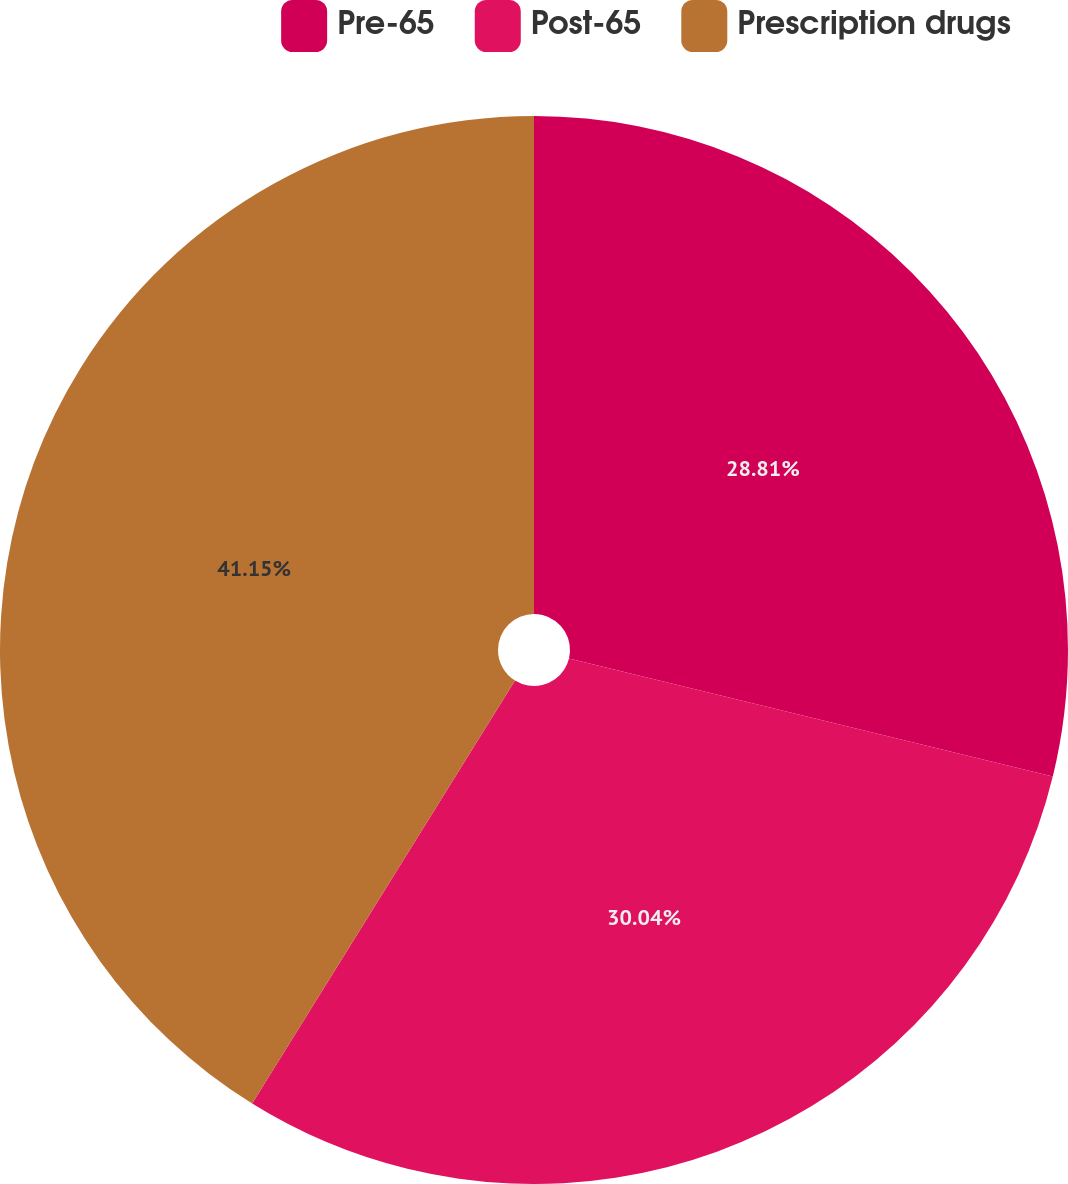<chart> <loc_0><loc_0><loc_500><loc_500><pie_chart><fcel>Pre-65<fcel>Post-65<fcel>Prescription drugs<nl><fcel>28.81%<fcel>30.04%<fcel>41.15%<nl></chart> 